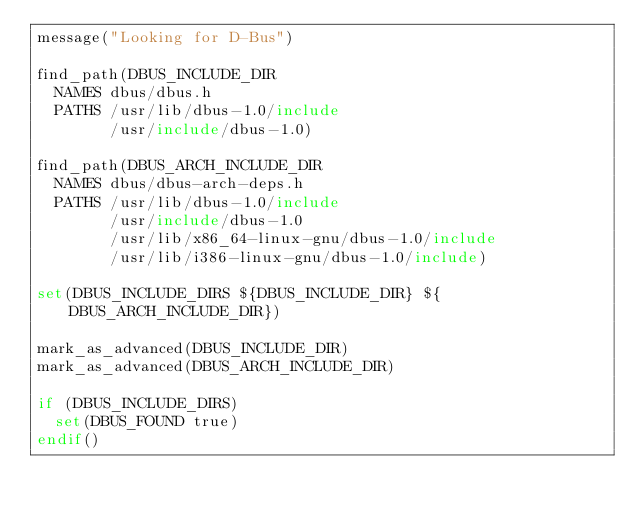<code> <loc_0><loc_0><loc_500><loc_500><_CMake_>message("Looking for D-Bus")

find_path(DBUS_INCLUDE_DIR
	NAMES dbus/dbus.h
	PATHS /usr/lib/dbus-1.0/include
	      /usr/include/dbus-1.0)

find_path(DBUS_ARCH_INCLUDE_DIR
	NAMES dbus/dbus-arch-deps.h
	PATHS /usr/lib/dbus-1.0/include
	      /usr/include/dbus-1.0
	      /usr/lib/x86_64-linux-gnu/dbus-1.0/include
	      /usr/lib/i386-linux-gnu/dbus-1.0/include)

set(DBUS_INCLUDE_DIRS ${DBUS_INCLUDE_DIR} ${DBUS_ARCH_INCLUDE_DIR})

mark_as_advanced(DBUS_INCLUDE_DIR)
mark_as_advanced(DBUS_ARCH_INCLUDE_DIR)

if (DBUS_INCLUDE_DIRS)
	set(DBUS_FOUND true)
endif()
</code> 